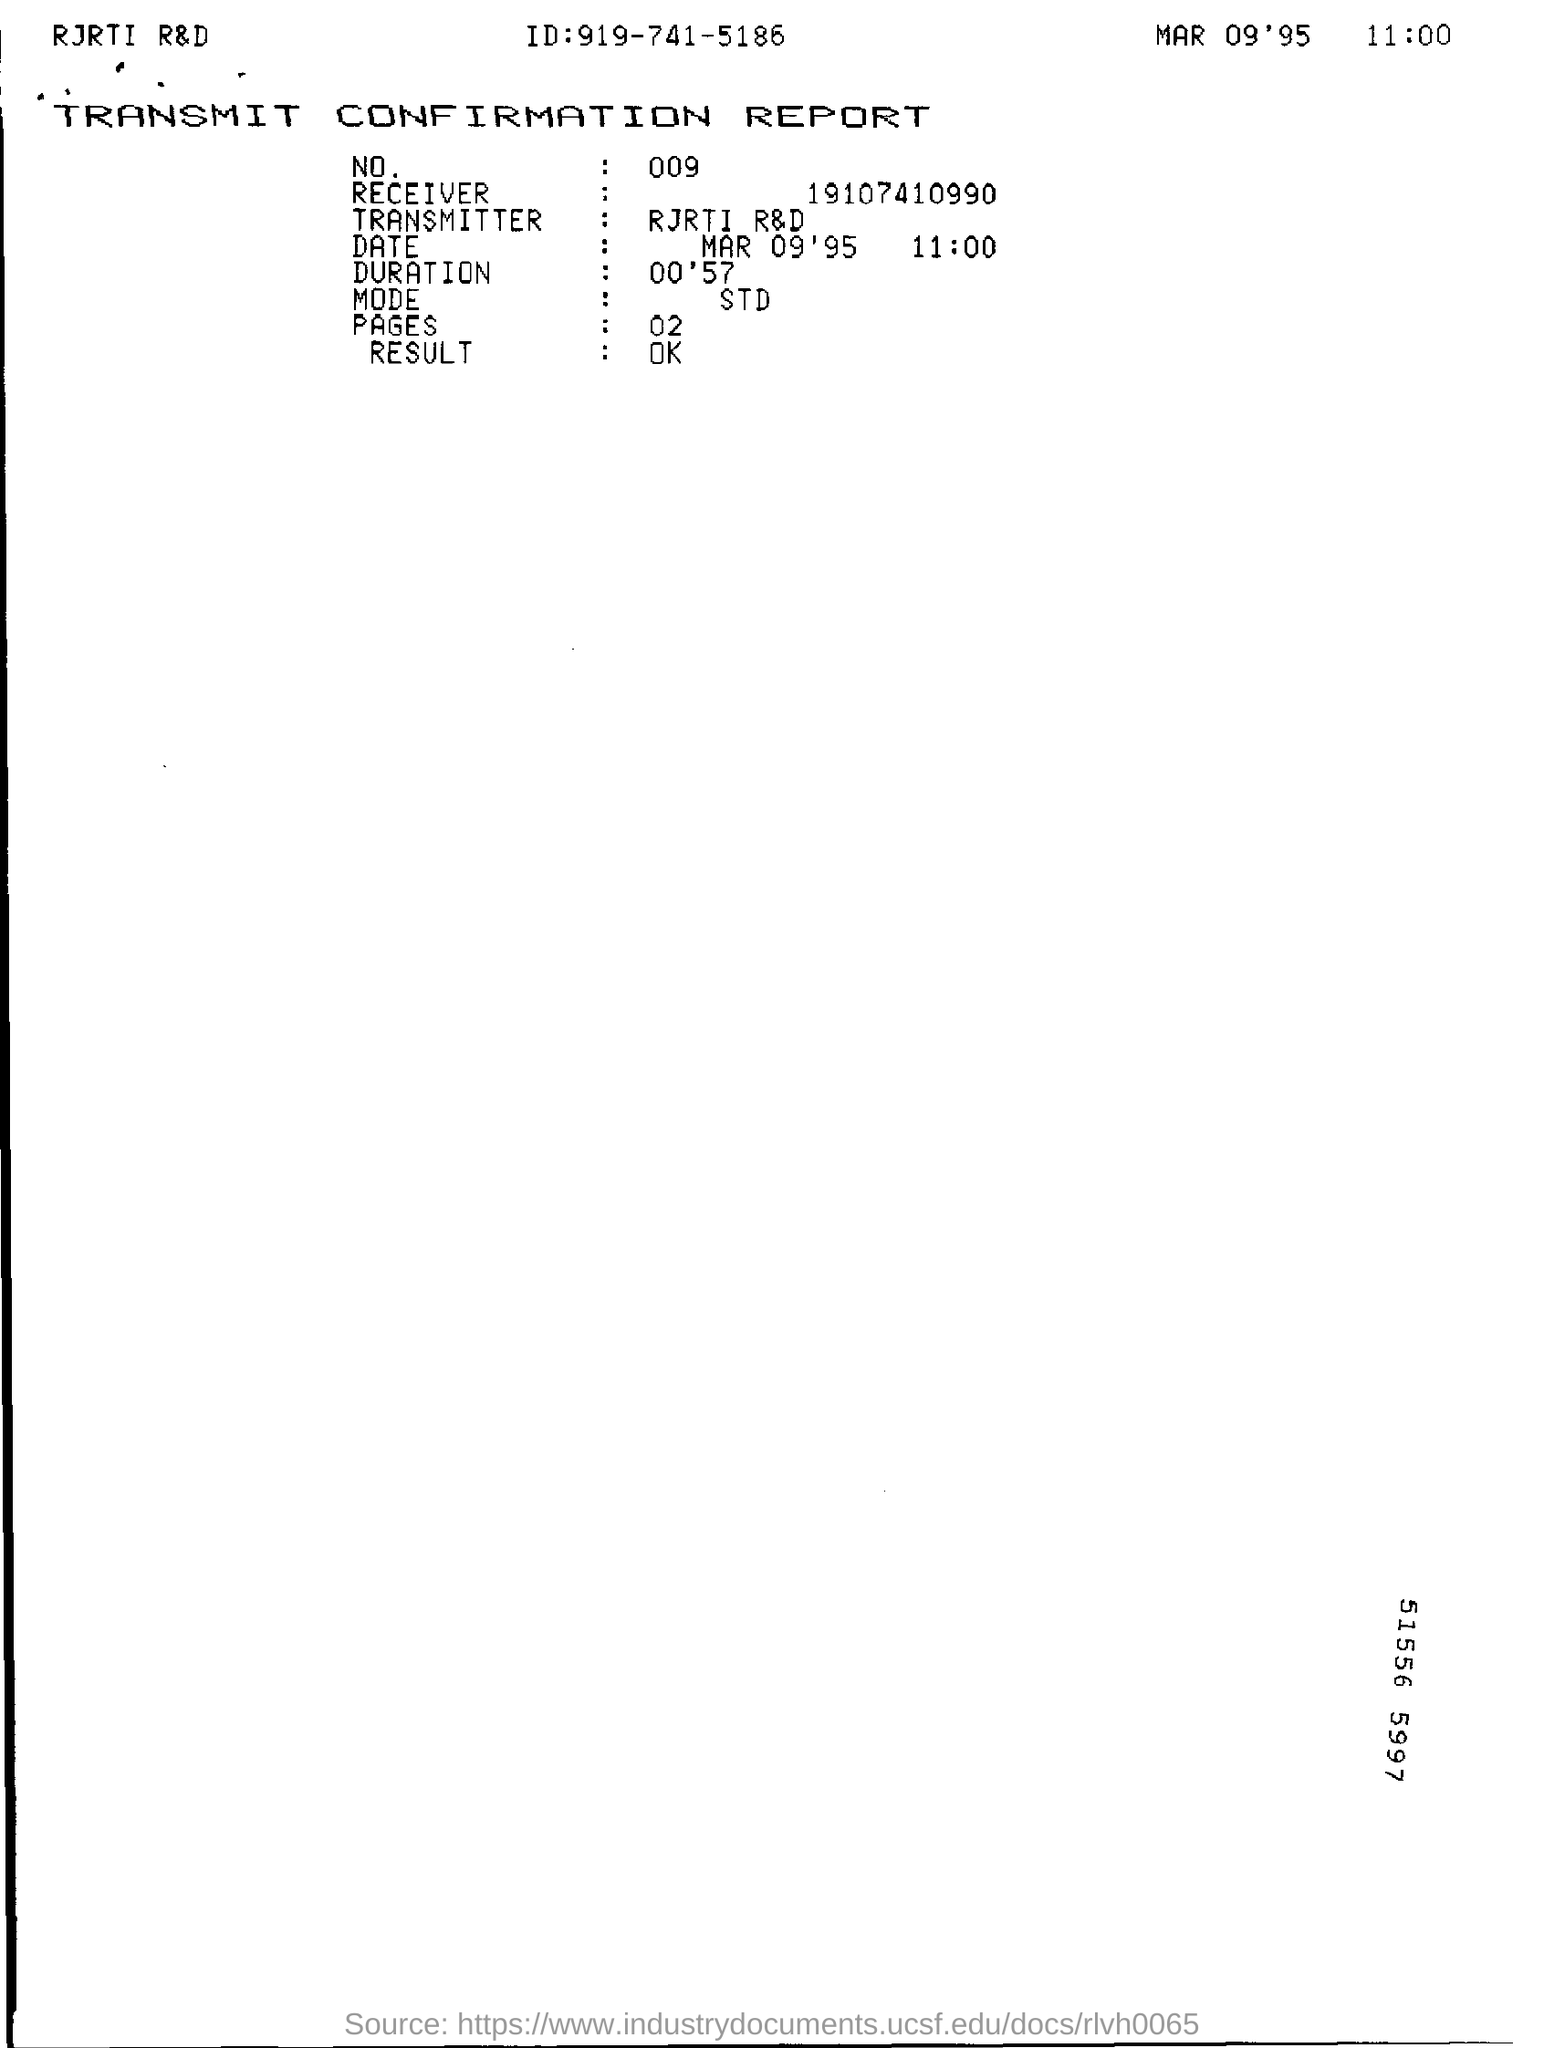List a handful of essential elements in this visual. The document is known as the TRANSMIT CONFIRMATION REPORT. The time indicated in the document is 11:00. 